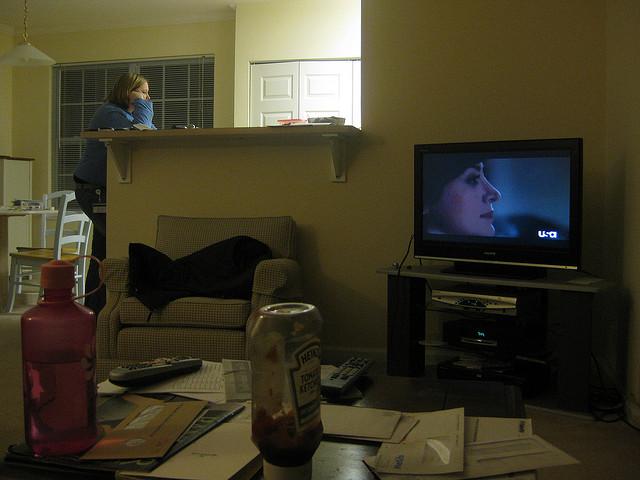How many chairs are there?
Give a very brief answer. 2. How many chairs are visible?
Quick response, please. 2. Does the room appear clean?
Answer briefly. No. Is this a TV or a computer?
Answer briefly. Tv. What show is on TV?
Keep it brief. New girl. Is there art on the wall?
Short answer required. No. Is the television a flat screen?
Write a very short answer. Yes. Is the screen on?
Give a very brief answer. Yes. Are the chairs red?
Be succinct. No. Is the tv on?
Write a very short answer. Yes. What TV station is this?
Short answer required. Usa. Are they watching a movie?
Give a very brief answer. Yes. Is the television on?
Keep it brief. Yes. Are there people in the room?
Write a very short answer. Yes. Is this a new television?
Keep it brief. Yes. Is there a man on the TV?
Give a very brief answer. No. What are the people using for their TV?
Keep it brief. Watching. Where is the bottle of ketchup?
Quick response, please. Table. What is the best distance to watch television?
Answer briefly. 8 feet. What does the TV say?
Write a very short answer. Usa. 